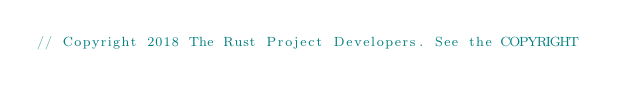Convert code to text. <code><loc_0><loc_0><loc_500><loc_500><_Rust_>// Copyright 2018 The Rust Project Developers. See the COPYRIGHT</code> 